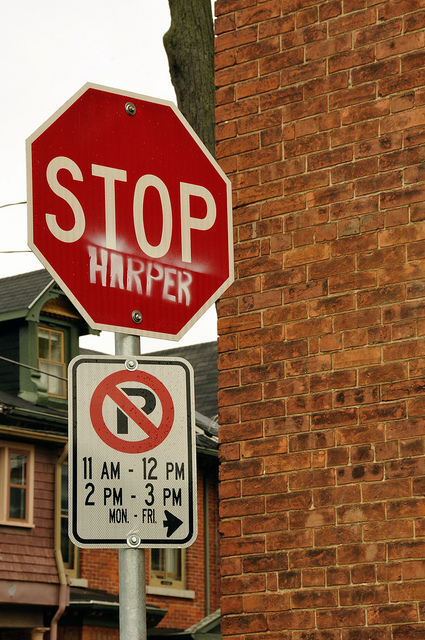<image>What day of the week is the sign not applicable? It is ambiguous what day of the week the sign is not applicable, but it can be Saturday and Sunday. What share are the two signs? I am not sure. The signs may be red in color or could have octagon and rectangle shapes. What day of the week is the sign not applicable? I am not sure on what day of the week the sign is not applicable. It can be on weekends, specifically Saturday and Sunday. What share are the two signs? I don't know what share the two signs are. The options are octagon and rectangle, red, or unknown. 